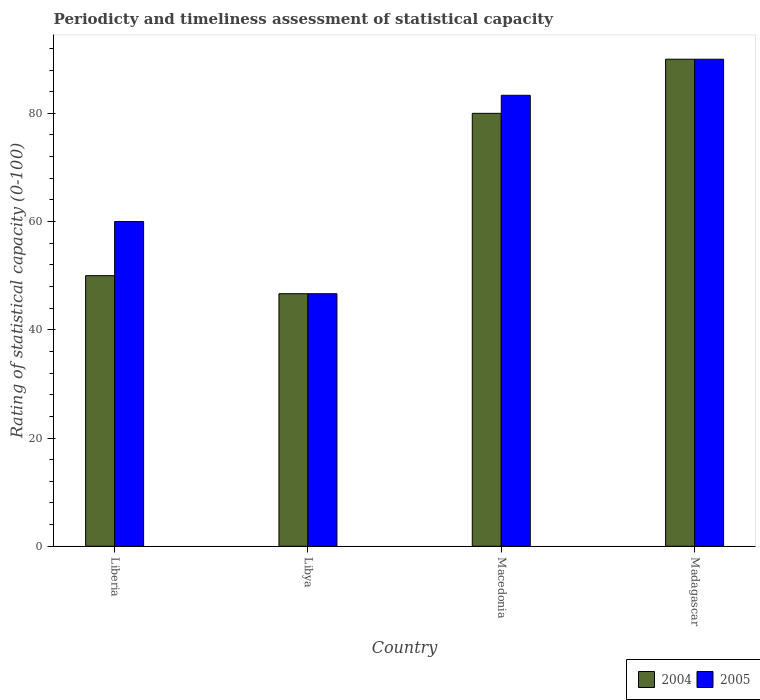How many different coloured bars are there?
Offer a terse response. 2. How many groups of bars are there?
Provide a succinct answer. 4. Are the number of bars per tick equal to the number of legend labels?
Provide a succinct answer. Yes. How many bars are there on the 1st tick from the right?
Your response must be concise. 2. What is the label of the 1st group of bars from the left?
Keep it short and to the point. Liberia. What is the rating of statistical capacity in 2005 in Macedonia?
Your response must be concise. 83.33. Across all countries, what is the maximum rating of statistical capacity in 2004?
Give a very brief answer. 90. Across all countries, what is the minimum rating of statistical capacity in 2004?
Offer a very short reply. 46.67. In which country was the rating of statistical capacity in 2004 maximum?
Ensure brevity in your answer.  Madagascar. In which country was the rating of statistical capacity in 2004 minimum?
Ensure brevity in your answer.  Libya. What is the total rating of statistical capacity in 2005 in the graph?
Your answer should be compact. 280. What is the difference between the rating of statistical capacity in 2005 in Libya and that in Macedonia?
Give a very brief answer. -36.67. What is the average rating of statistical capacity in 2005 per country?
Provide a succinct answer. 70. What is the difference between the rating of statistical capacity of/in 2005 and rating of statistical capacity of/in 2004 in Macedonia?
Provide a short and direct response. 3.33. In how many countries, is the rating of statistical capacity in 2005 greater than 16?
Offer a very short reply. 4. What is the ratio of the rating of statistical capacity in 2005 in Macedonia to that in Madagascar?
Offer a very short reply. 0.93. What is the difference between the highest and the second highest rating of statistical capacity in 2005?
Make the answer very short. 6.67. What is the difference between the highest and the lowest rating of statistical capacity in 2005?
Keep it short and to the point. 43.33. In how many countries, is the rating of statistical capacity in 2005 greater than the average rating of statistical capacity in 2005 taken over all countries?
Make the answer very short. 2. What does the 2nd bar from the right in Madagascar represents?
Your response must be concise. 2004. How many bars are there?
Offer a terse response. 8. Are all the bars in the graph horizontal?
Provide a succinct answer. No. Does the graph contain any zero values?
Your answer should be very brief. No. Does the graph contain grids?
Ensure brevity in your answer.  No. What is the title of the graph?
Your answer should be very brief. Periodicty and timeliness assessment of statistical capacity. What is the label or title of the Y-axis?
Offer a very short reply. Rating of statistical capacity (0-100). What is the Rating of statistical capacity (0-100) in 2004 in Liberia?
Give a very brief answer. 50. What is the Rating of statistical capacity (0-100) of 2004 in Libya?
Provide a short and direct response. 46.67. What is the Rating of statistical capacity (0-100) in 2005 in Libya?
Keep it short and to the point. 46.67. What is the Rating of statistical capacity (0-100) in 2005 in Macedonia?
Offer a terse response. 83.33. What is the Rating of statistical capacity (0-100) in 2004 in Madagascar?
Keep it short and to the point. 90. Across all countries, what is the maximum Rating of statistical capacity (0-100) in 2004?
Offer a terse response. 90. Across all countries, what is the minimum Rating of statistical capacity (0-100) of 2004?
Your response must be concise. 46.67. Across all countries, what is the minimum Rating of statistical capacity (0-100) in 2005?
Offer a terse response. 46.67. What is the total Rating of statistical capacity (0-100) of 2004 in the graph?
Provide a succinct answer. 266.67. What is the total Rating of statistical capacity (0-100) of 2005 in the graph?
Offer a very short reply. 280. What is the difference between the Rating of statistical capacity (0-100) of 2005 in Liberia and that in Libya?
Ensure brevity in your answer.  13.33. What is the difference between the Rating of statistical capacity (0-100) of 2005 in Liberia and that in Macedonia?
Give a very brief answer. -23.33. What is the difference between the Rating of statistical capacity (0-100) in 2004 in Liberia and that in Madagascar?
Ensure brevity in your answer.  -40. What is the difference between the Rating of statistical capacity (0-100) of 2004 in Libya and that in Macedonia?
Your answer should be very brief. -33.33. What is the difference between the Rating of statistical capacity (0-100) of 2005 in Libya and that in Macedonia?
Give a very brief answer. -36.67. What is the difference between the Rating of statistical capacity (0-100) in 2004 in Libya and that in Madagascar?
Your response must be concise. -43.33. What is the difference between the Rating of statistical capacity (0-100) of 2005 in Libya and that in Madagascar?
Offer a terse response. -43.33. What is the difference between the Rating of statistical capacity (0-100) in 2005 in Macedonia and that in Madagascar?
Provide a succinct answer. -6.67. What is the difference between the Rating of statistical capacity (0-100) in 2004 in Liberia and the Rating of statistical capacity (0-100) in 2005 in Libya?
Keep it short and to the point. 3.33. What is the difference between the Rating of statistical capacity (0-100) in 2004 in Liberia and the Rating of statistical capacity (0-100) in 2005 in Macedonia?
Your answer should be very brief. -33.33. What is the difference between the Rating of statistical capacity (0-100) in 2004 in Libya and the Rating of statistical capacity (0-100) in 2005 in Macedonia?
Make the answer very short. -36.67. What is the difference between the Rating of statistical capacity (0-100) in 2004 in Libya and the Rating of statistical capacity (0-100) in 2005 in Madagascar?
Offer a very short reply. -43.33. What is the average Rating of statistical capacity (0-100) in 2004 per country?
Keep it short and to the point. 66.67. What is the difference between the Rating of statistical capacity (0-100) of 2004 and Rating of statistical capacity (0-100) of 2005 in Liberia?
Provide a short and direct response. -10. What is the difference between the Rating of statistical capacity (0-100) of 2004 and Rating of statistical capacity (0-100) of 2005 in Libya?
Make the answer very short. 0. What is the ratio of the Rating of statistical capacity (0-100) of 2004 in Liberia to that in Libya?
Make the answer very short. 1.07. What is the ratio of the Rating of statistical capacity (0-100) of 2005 in Liberia to that in Libya?
Give a very brief answer. 1.29. What is the ratio of the Rating of statistical capacity (0-100) in 2004 in Liberia to that in Macedonia?
Make the answer very short. 0.62. What is the ratio of the Rating of statistical capacity (0-100) of 2005 in Liberia to that in Macedonia?
Ensure brevity in your answer.  0.72. What is the ratio of the Rating of statistical capacity (0-100) of 2004 in Liberia to that in Madagascar?
Ensure brevity in your answer.  0.56. What is the ratio of the Rating of statistical capacity (0-100) of 2005 in Liberia to that in Madagascar?
Give a very brief answer. 0.67. What is the ratio of the Rating of statistical capacity (0-100) of 2004 in Libya to that in Macedonia?
Keep it short and to the point. 0.58. What is the ratio of the Rating of statistical capacity (0-100) of 2005 in Libya to that in Macedonia?
Give a very brief answer. 0.56. What is the ratio of the Rating of statistical capacity (0-100) in 2004 in Libya to that in Madagascar?
Keep it short and to the point. 0.52. What is the ratio of the Rating of statistical capacity (0-100) in 2005 in Libya to that in Madagascar?
Ensure brevity in your answer.  0.52. What is the ratio of the Rating of statistical capacity (0-100) in 2005 in Macedonia to that in Madagascar?
Offer a terse response. 0.93. What is the difference between the highest and the second highest Rating of statistical capacity (0-100) in 2004?
Offer a very short reply. 10. What is the difference between the highest and the second highest Rating of statistical capacity (0-100) of 2005?
Your response must be concise. 6.67. What is the difference between the highest and the lowest Rating of statistical capacity (0-100) in 2004?
Your response must be concise. 43.33. What is the difference between the highest and the lowest Rating of statistical capacity (0-100) of 2005?
Your answer should be compact. 43.33. 